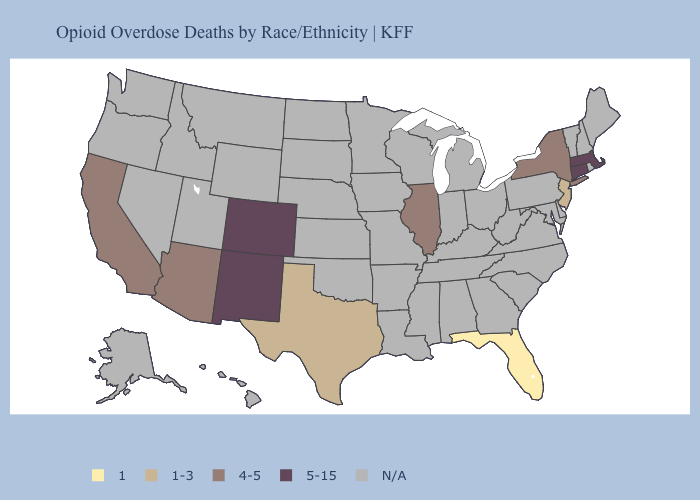What is the lowest value in the USA?
Give a very brief answer. 1. What is the highest value in the USA?
Concise answer only. 5-15. What is the lowest value in the USA?
Answer briefly. 1. What is the highest value in the Northeast ?
Concise answer only. 5-15. How many symbols are there in the legend?
Keep it brief. 5. Name the states that have a value in the range 4-5?
Short answer required. Arizona, California, Illinois, New York. Which states have the lowest value in the USA?
Answer briefly. Florida. What is the value of Kansas?
Keep it brief. N/A. Which states have the highest value in the USA?
Short answer required. Colorado, Connecticut, Massachusetts, New Mexico. Among the states that border Massachusetts , does New York have the lowest value?
Short answer required. Yes. What is the highest value in the Northeast ?
Quick response, please. 5-15. 